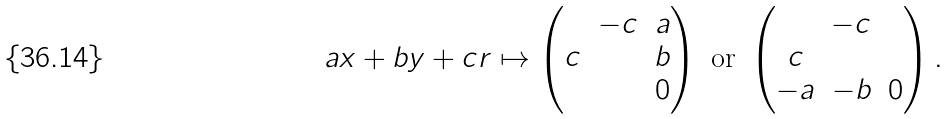Convert formula to latex. <formula><loc_0><loc_0><loc_500><loc_500>a x + b y + c r & \mapsto \begin{pmatrix} & - c & a \\ c & & b \\ & & 0 \end{pmatrix} \text { or } \begin{pmatrix} & - c & \\ c & & \\ - a & - b & 0 \end{pmatrix} .</formula> 